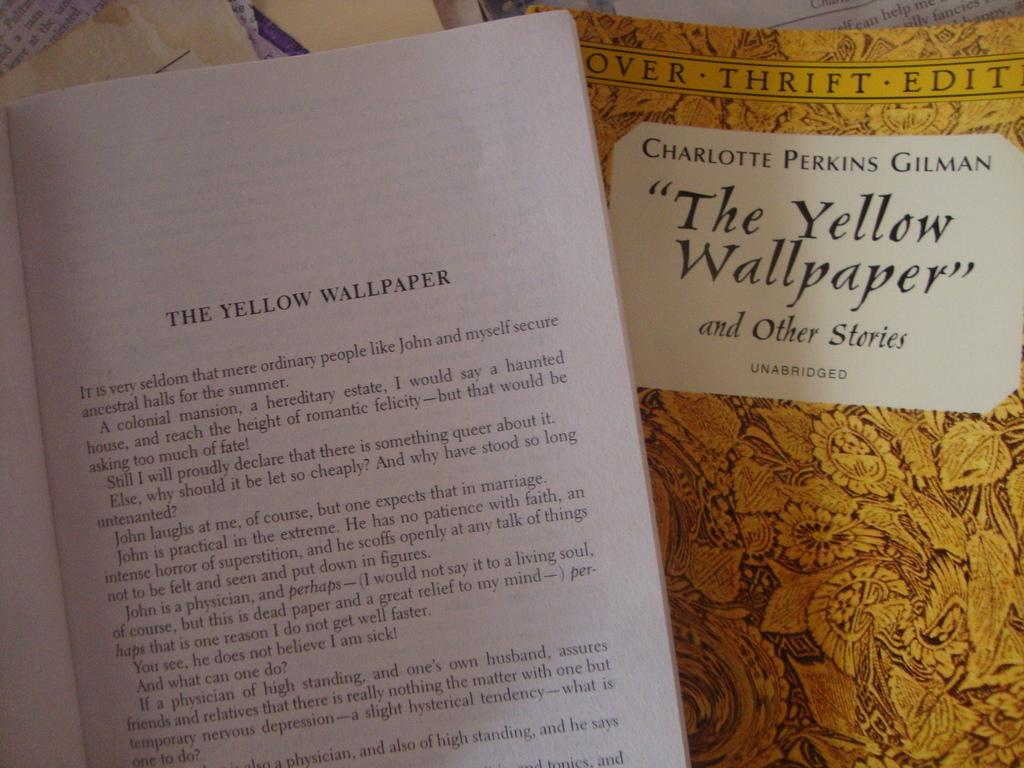<image>
Provide a brief description of the given image. Chapter booklet and thrift edition booklet of the yellow wallpaper 